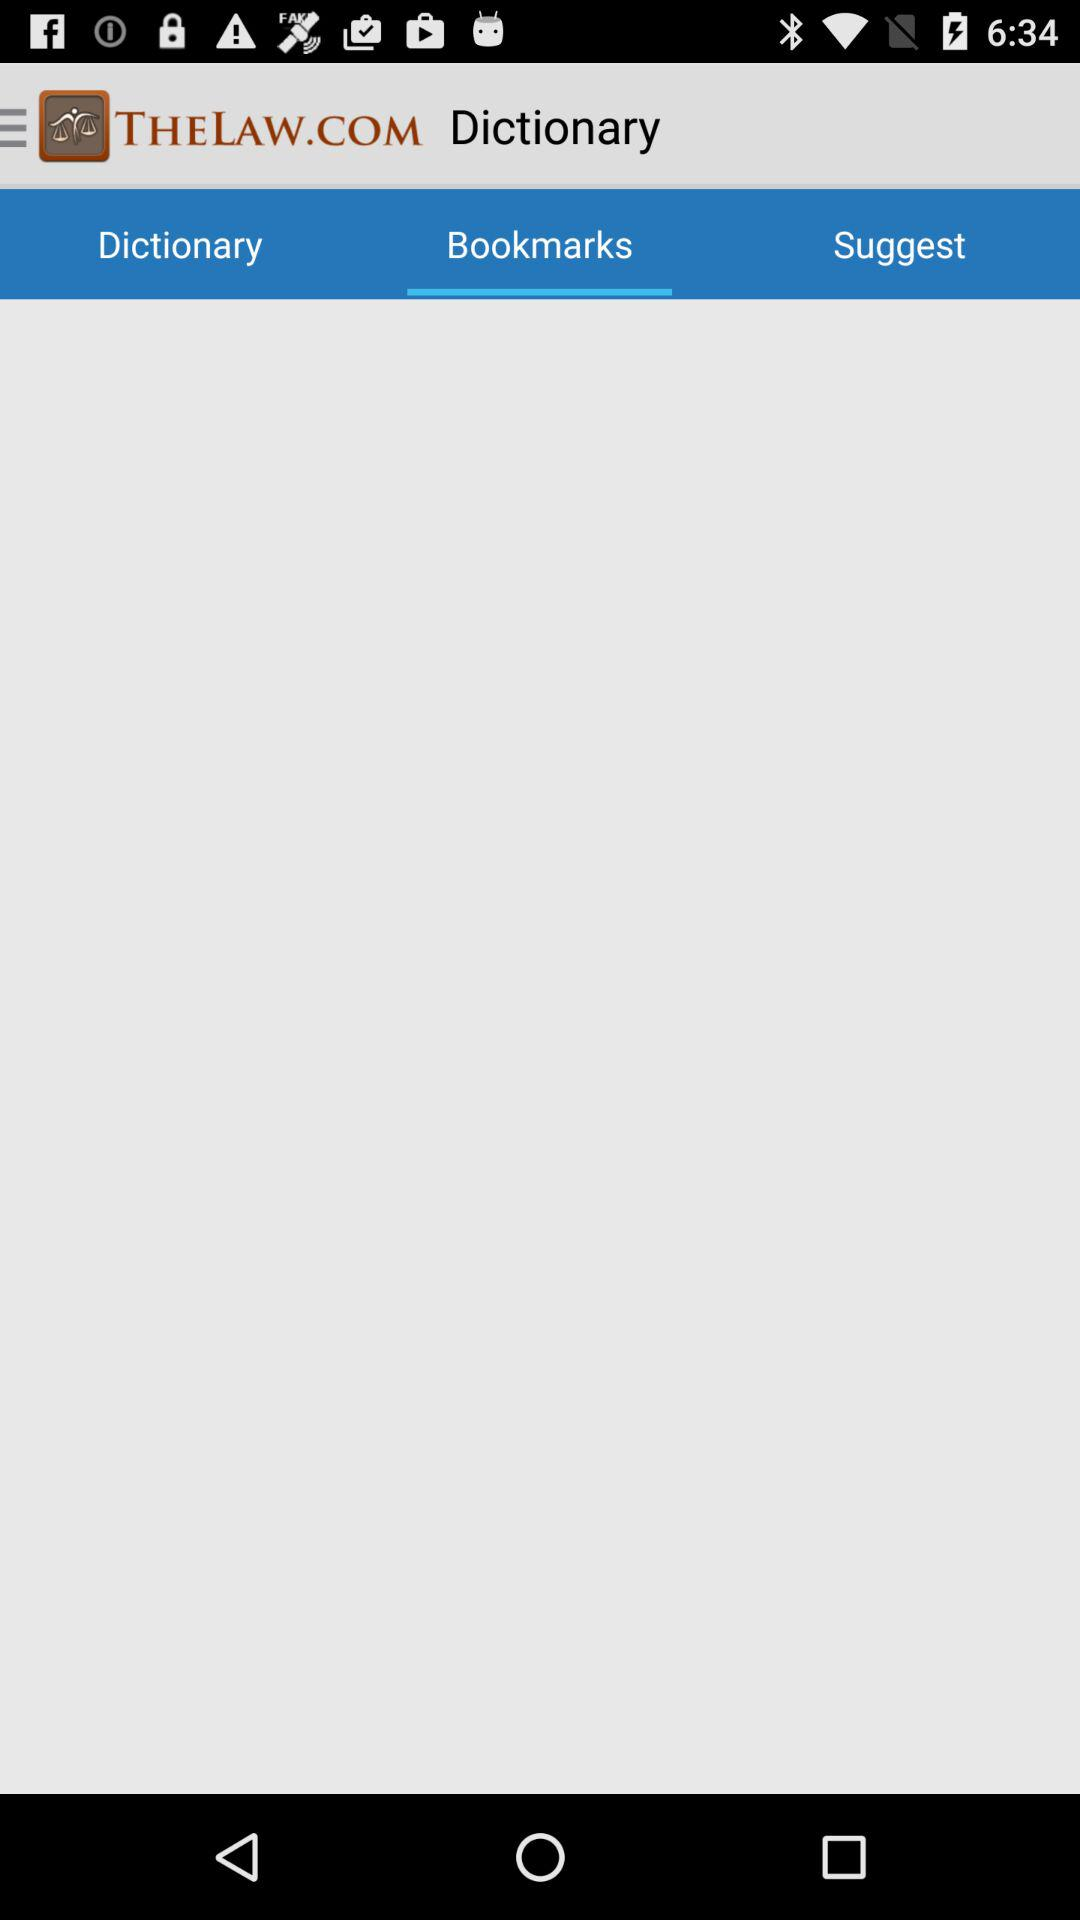Which tab is selected? The selected tab is "Bookmarks". 